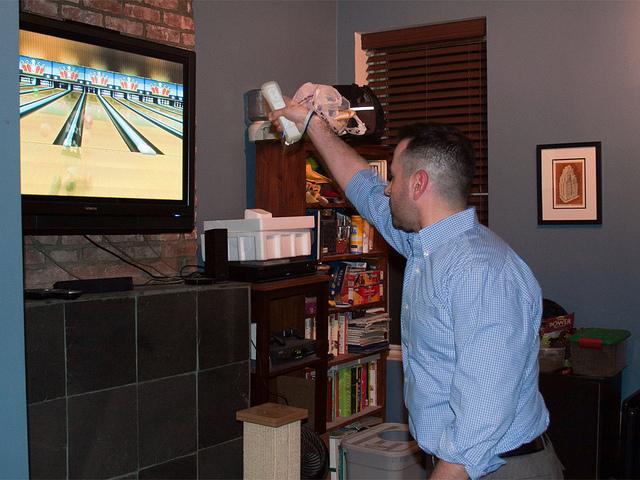What game is the man playing?
Give a very brief answer. Wii. Are the blinds open or closed?
Answer briefly. Closed. What sport is the man playing on the game?
Short answer required. Bowling. Is the man in the blue shirt to old to play video games?
Quick response, please. No. What is in the man's hand?
Answer briefly. Wii controller. 